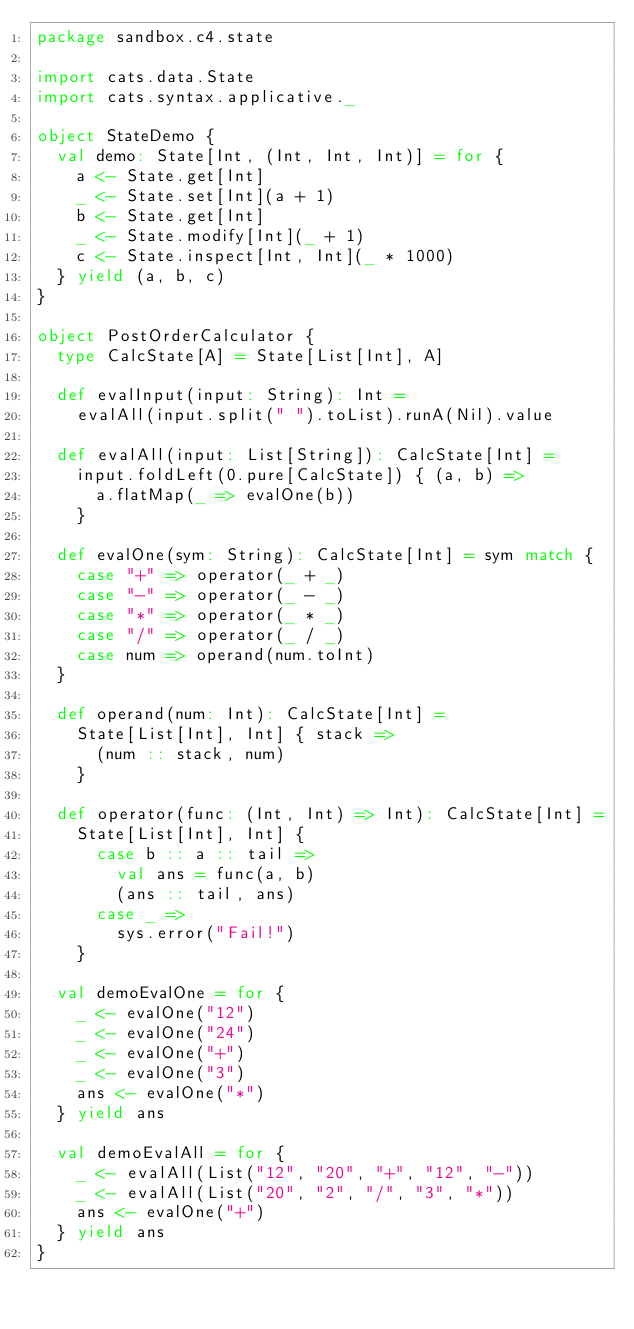Convert code to text. <code><loc_0><loc_0><loc_500><loc_500><_Scala_>package sandbox.c4.state

import cats.data.State
import cats.syntax.applicative._

object StateDemo {
  val demo: State[Int, (Int, Int, Int)] = for {
    a <- State.get[Int]
    _ <- State.set[Int](a + 1)
    b <- State.get[Int]
    _ <- State.modify[Int](_ + 1)
    c <- State.inspect[Int, Int](_ * 1000)
  } yield (a, b, c)
}

object PostOrderCalculator {
  type CalcState[A] = State[List[Int], A]

  def evalInput(input: String): Int =
    evalAll(input.split(" ").toList).runA(Nil).value

  def evalAll(input: List[String]): CalcState[Int] =
    input.foldLeft(0.pure[CalcState]) { (a, b) =>
      a.flatMap(_ => evalOne(b))
    }

  def evalOne(sym: String): CalcState[Int] = sym match {
    case "+" => operator(_ + _)
    case "-" => operator(_ - _)
    case "*" => operator(_ * _)
    case "/" => operator(_ / _)
    case num => operand(num.toInt)
  }

  def operand(num: Int): CalcState[Int] =
    State[List[Int], Int] { stack =>
      (num :: stack, num)
    }

  def operator(func: (Int, Int) => Int): CalcState[Int] =
    State[List[Int], Int] {
      case b :: a :: tail =>
        val ans = func(a, b)
        (ans :: tail, ans)
      case _ =>
        sys.error("Fail!")
    }

  val demoEvalOne = for {
    _ <- evalOne("12")
    _ <- evalOne("24")
    _ <- evalOne("+")
    _ <- evalOne("3")
    ans <- evalOne("*")
  } yield ans

  val demoEvalAll = for {
    _ <- evalAll(List("12", "20", "+", "12", "-"))
    _ <- evalAll(List("20", "2", "/", "3", "*"))
    ans <- evalOne("+")
  } yield ans
}
</code> 